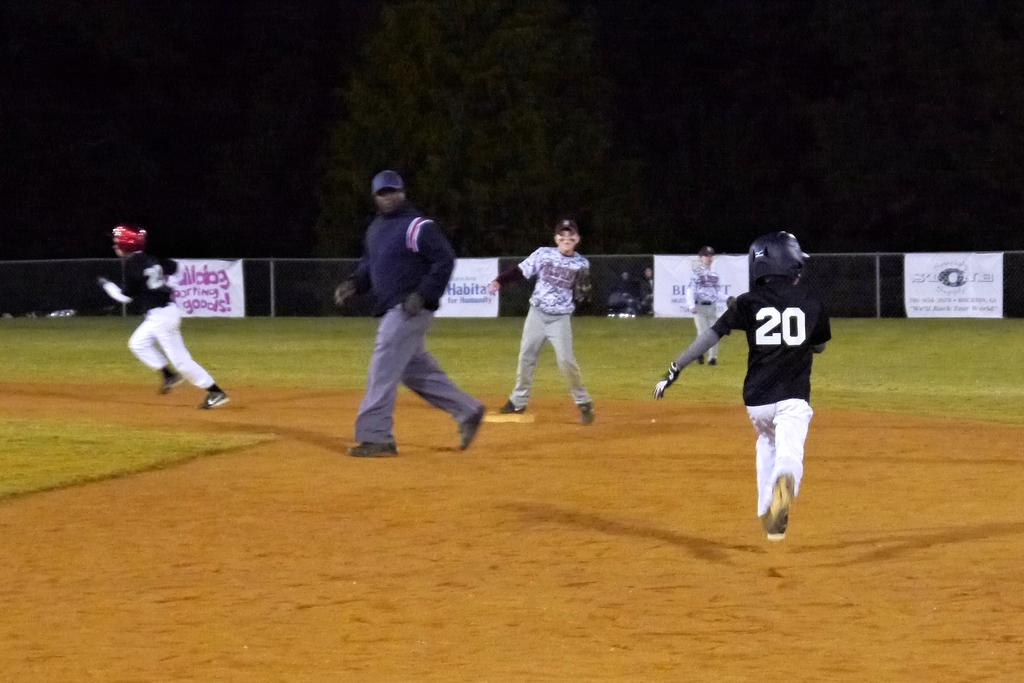What are the people in the image doing? The people in the image are running on the ground. What else can be seen in the image besides the people running? Banners and a tree are present in the image. How would you describe the background of the image? The background of the image is dark. How does the wrist of the person running feel in the heat? There is no information about the person's wrist or the temperature in the image, so it cannot be determined from the image. 